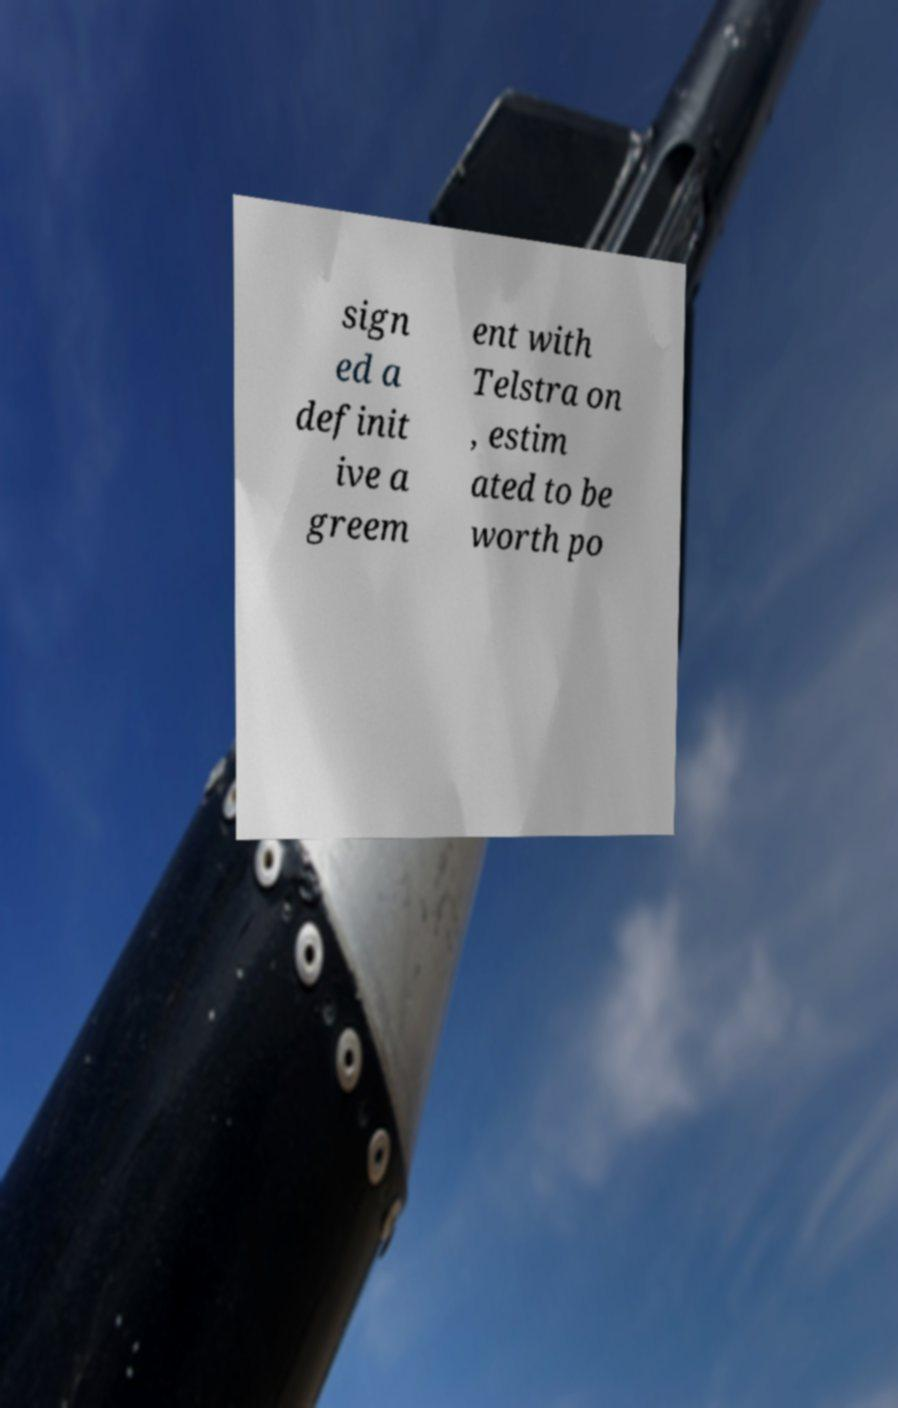Can you accurately transcribe the text from the provided image for me? sign ed a definit ive a greem ent with Telstra on , estim ated to be worth po 